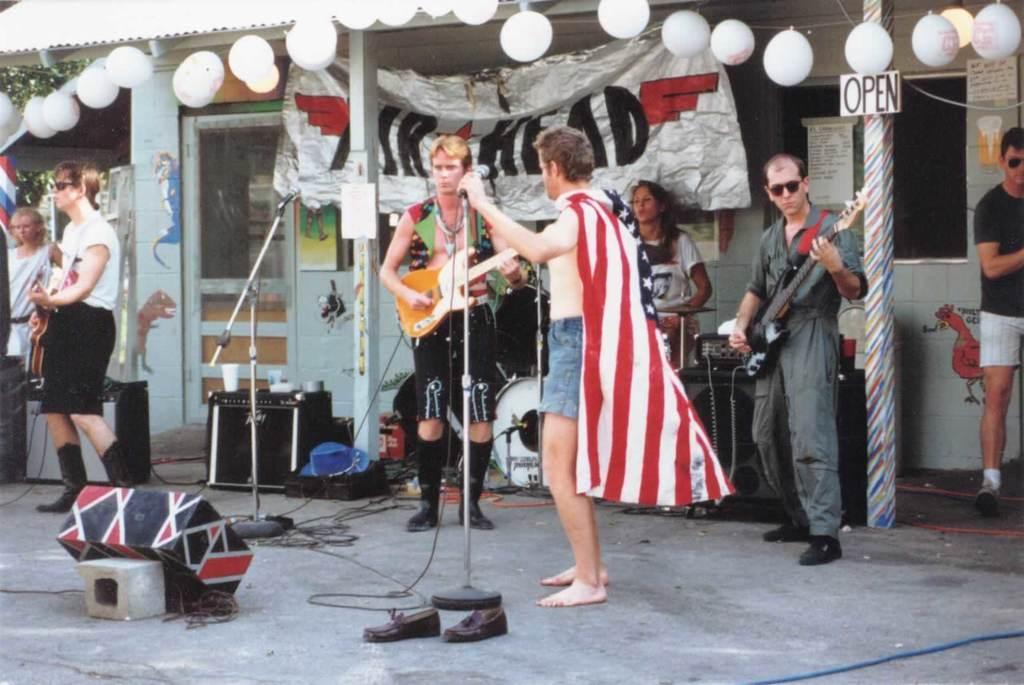Please provide a concise description of this image. In the picture I can see a few persons standing on the road and they are playing the musical instruments. I can see three men playing the guitar and I can see a man singing on a microphone. There is a woman in the background. I can see a man wearing a black color T-shirt and he is on the right side. I can see the balloons at the top of the picture. 